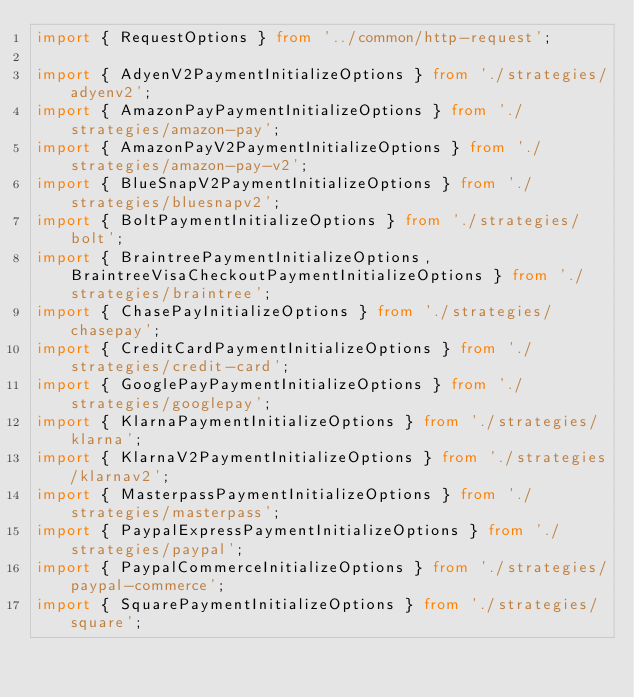Convert code to text. <code><loc_0><loc_0><loc_500><loc_500><_TypeScript_>import { RequestOptions } from '../common/http-request';

import { AdyenV2PaymentInitializeOptions } from './strategies/adyenv2';
import { AmazonPayPaymentInitializeOptions } from './strategies/amazon-pay';
import { AmazonPayV2PaymentInitializeOptions } from './strategies/amazon-pay-v2';
import { BlueSnapV2PaymentInitializeOptions } from './strategies/bluesnapv2';
import { BoltPaymentInitializeOptions } from './strategies/bolt';
import { BraintreePaymentInitializeOptions, BraintreeVisaCheckoutPaymentInitializeOptions } from './strategies/braintree';
import { ChasePayInitializeOptions } from './strategies/chasepay';
import { CreditCardPaymentInitializeOptions } from './strategies/credit-card';
import { GooglePayPaymentInitializeOptions } from './strategies/googlepay';
import { KlarnaPaymentInitializeOptions } from './strategies/klarna';
import { KlarnaV2PaymentInitializeOptions } from './strategies/klarnav2';
import { MasterpassPaymentInitializeOptions } from './strategies/masterpass';
import { PaypalExpressPaymentInitializeOptions } from './strategies/paypal';
import { PaypalCommerceInitializeOptions } from './strategies/paypal-commerce';
import { SquarePaymentInitializeOptions } from './strategies/square';</code> 